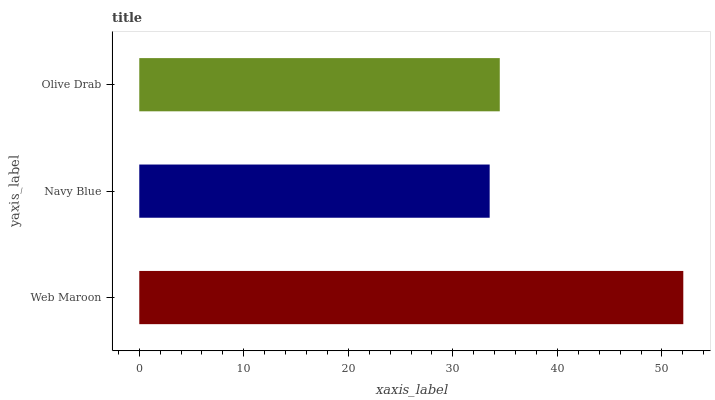Is Navy Blue the minimum?
Answer yes or no. Yes. Is Web Maroon the maximum?
Answer yes or no. Yes. Is Olive Drab the minimum?
Answer yes or no. No. Is Olive Drab the maximum?
Answer yes or no. No. Is Olive Drab greater than Navy Blue?
Answer yes or no. Yes. Is Navy Blue less than Olive Drab?
Answer yes or no. Yes. Is Navy Blue greater than Olive Drab?
Answer yes or no. No. Is Olive Drab less than Navy Blue?
Answer yes or no. No. Is Olive Drab the high median?
Answer yes or no. Yes. Is Olive Drab the low median?
Answer yes or no. Yes. Is Web Maroon the high median?
Answer yes or no. No. Is Web Maroon the low median?
Answer yes or no. No. 